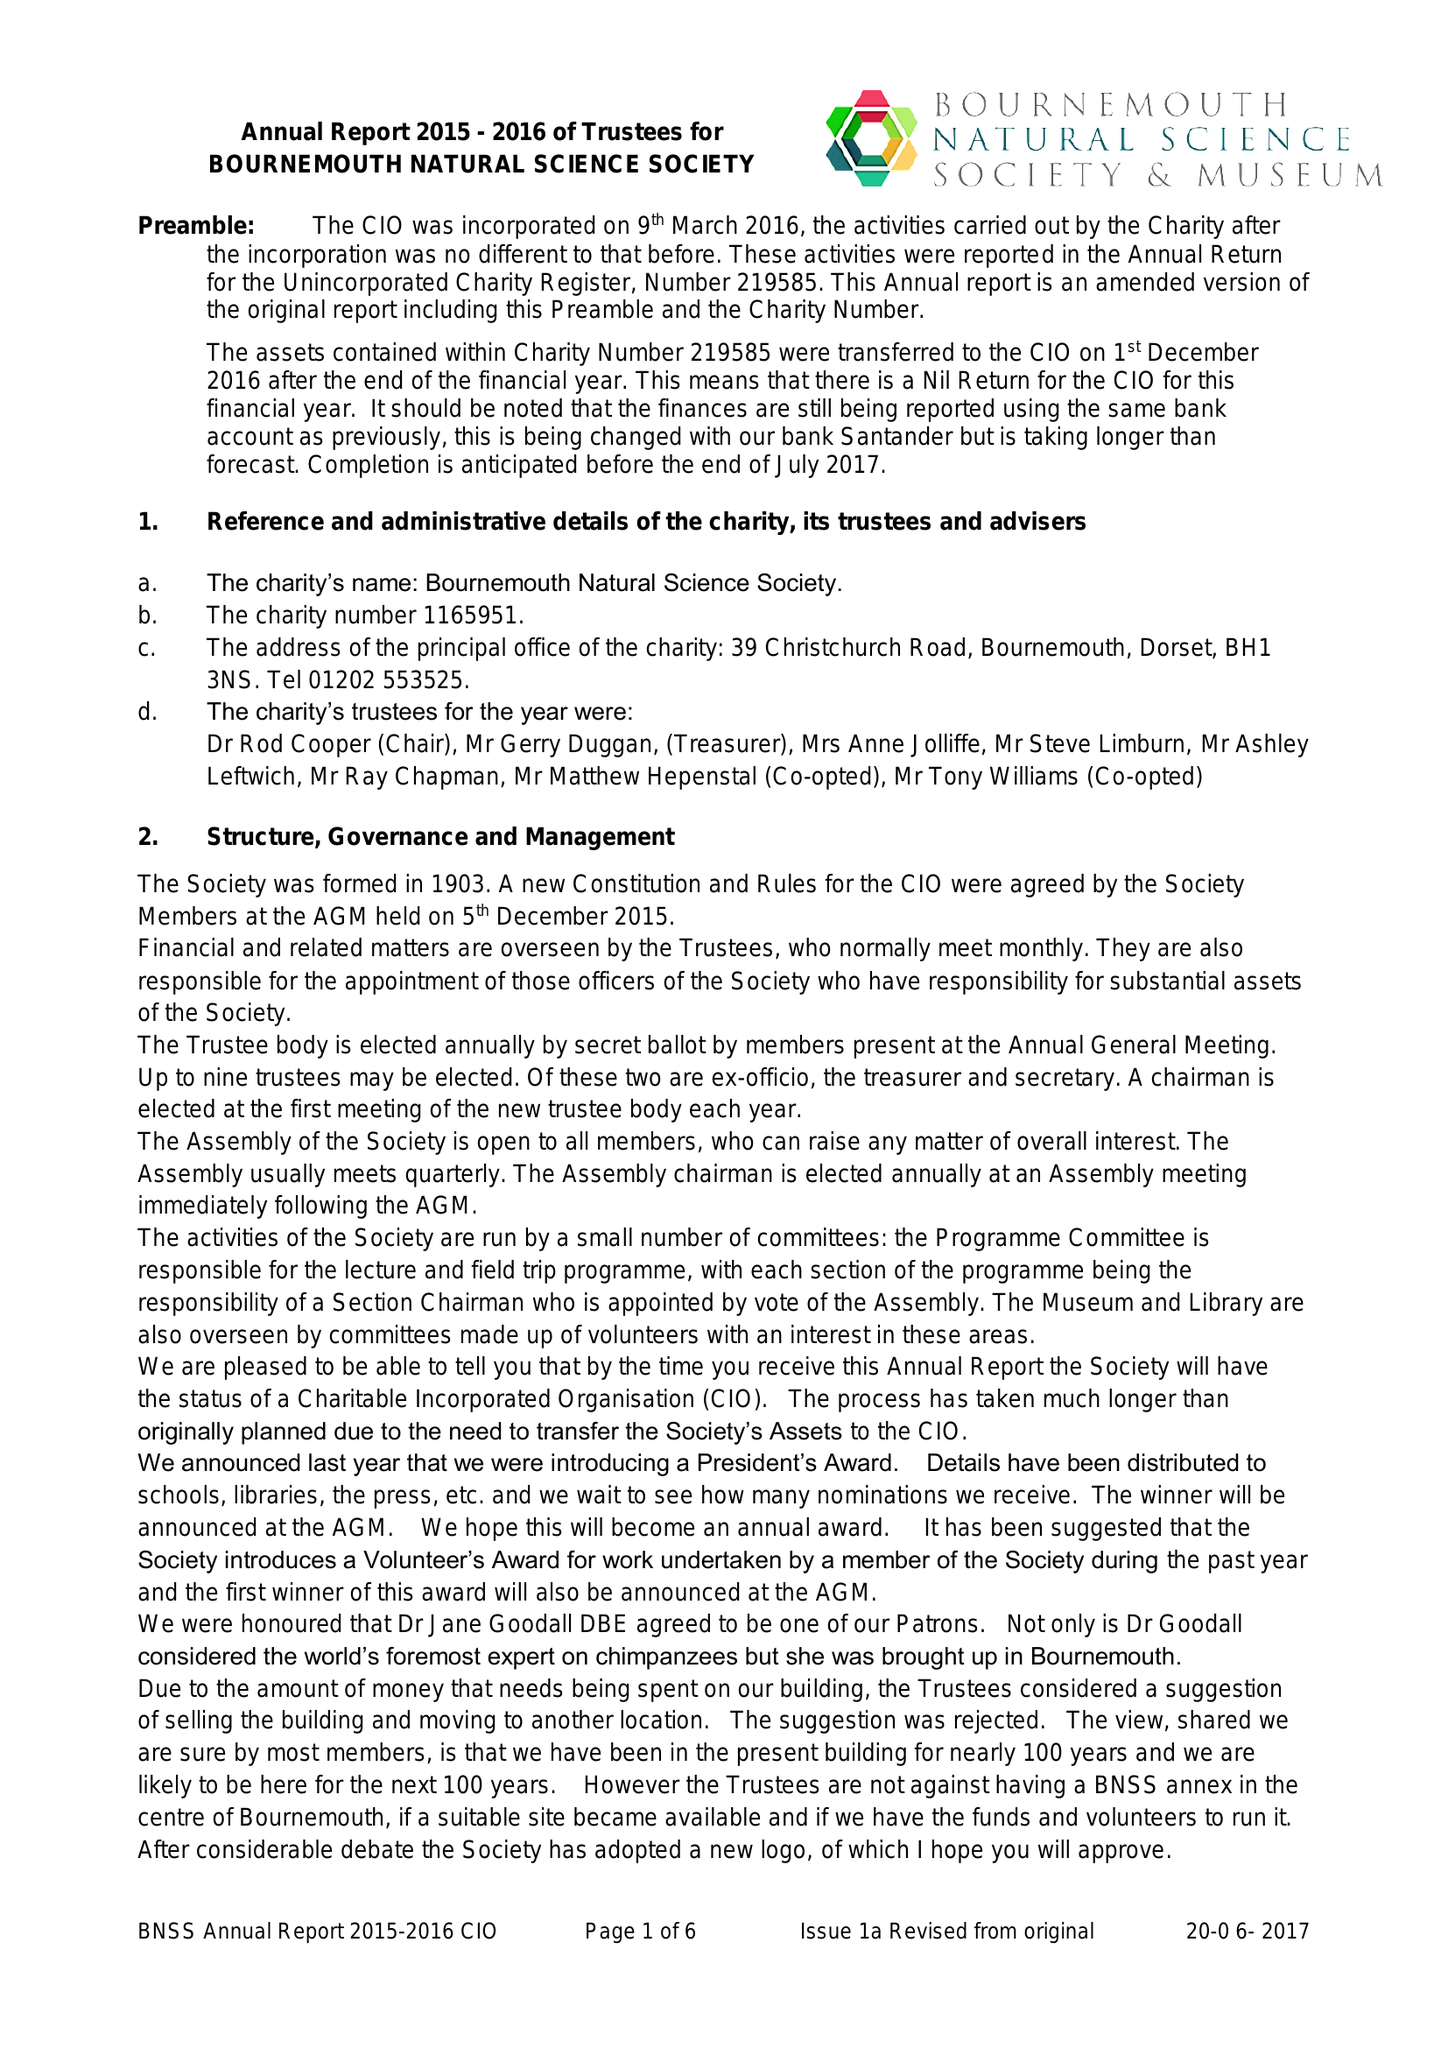What is the value for the charity_number?
Answer the question using a single word or phrase. 1165951 